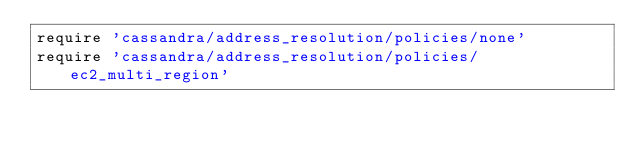Convert code to text. <code><loc_0><loc_0><loc_500><loc_500><_Ruby_>require 'cassandra/address_resolution/policies/none'
require 'cassandra/address_resolution/policies/ec2_multi_region'
</code> 